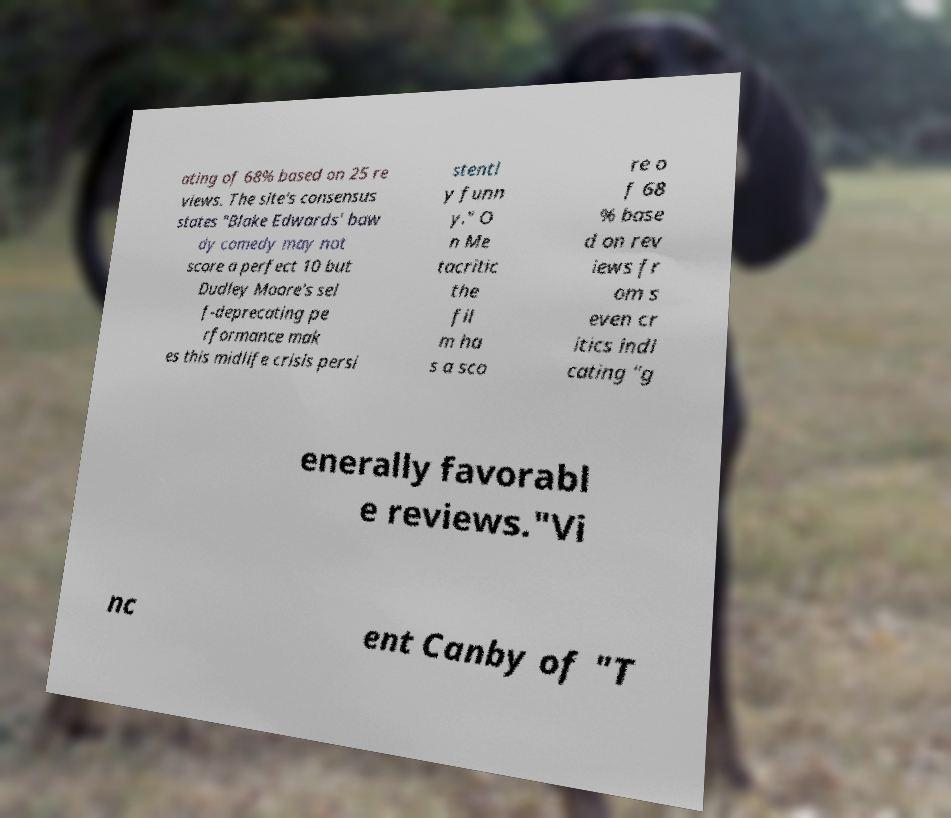For documentation purposes, I need the text within this image transcribed. Could you provide that? ating of 68% based on 25 re views. The site's consensus states "Blake Edwards' baw dy comedy may not score a perfect 10 but Dudley Moore's sel f-deprecating pe rformance mak es this midlife crisis persi stentl y funn y." O n Me tacritic the fil m ha s a sco re o f 68 % base d on rev iews fr om s even cr itics indi cating "g enerally favorabl e reviews."Vi nc ent Canby of "T 